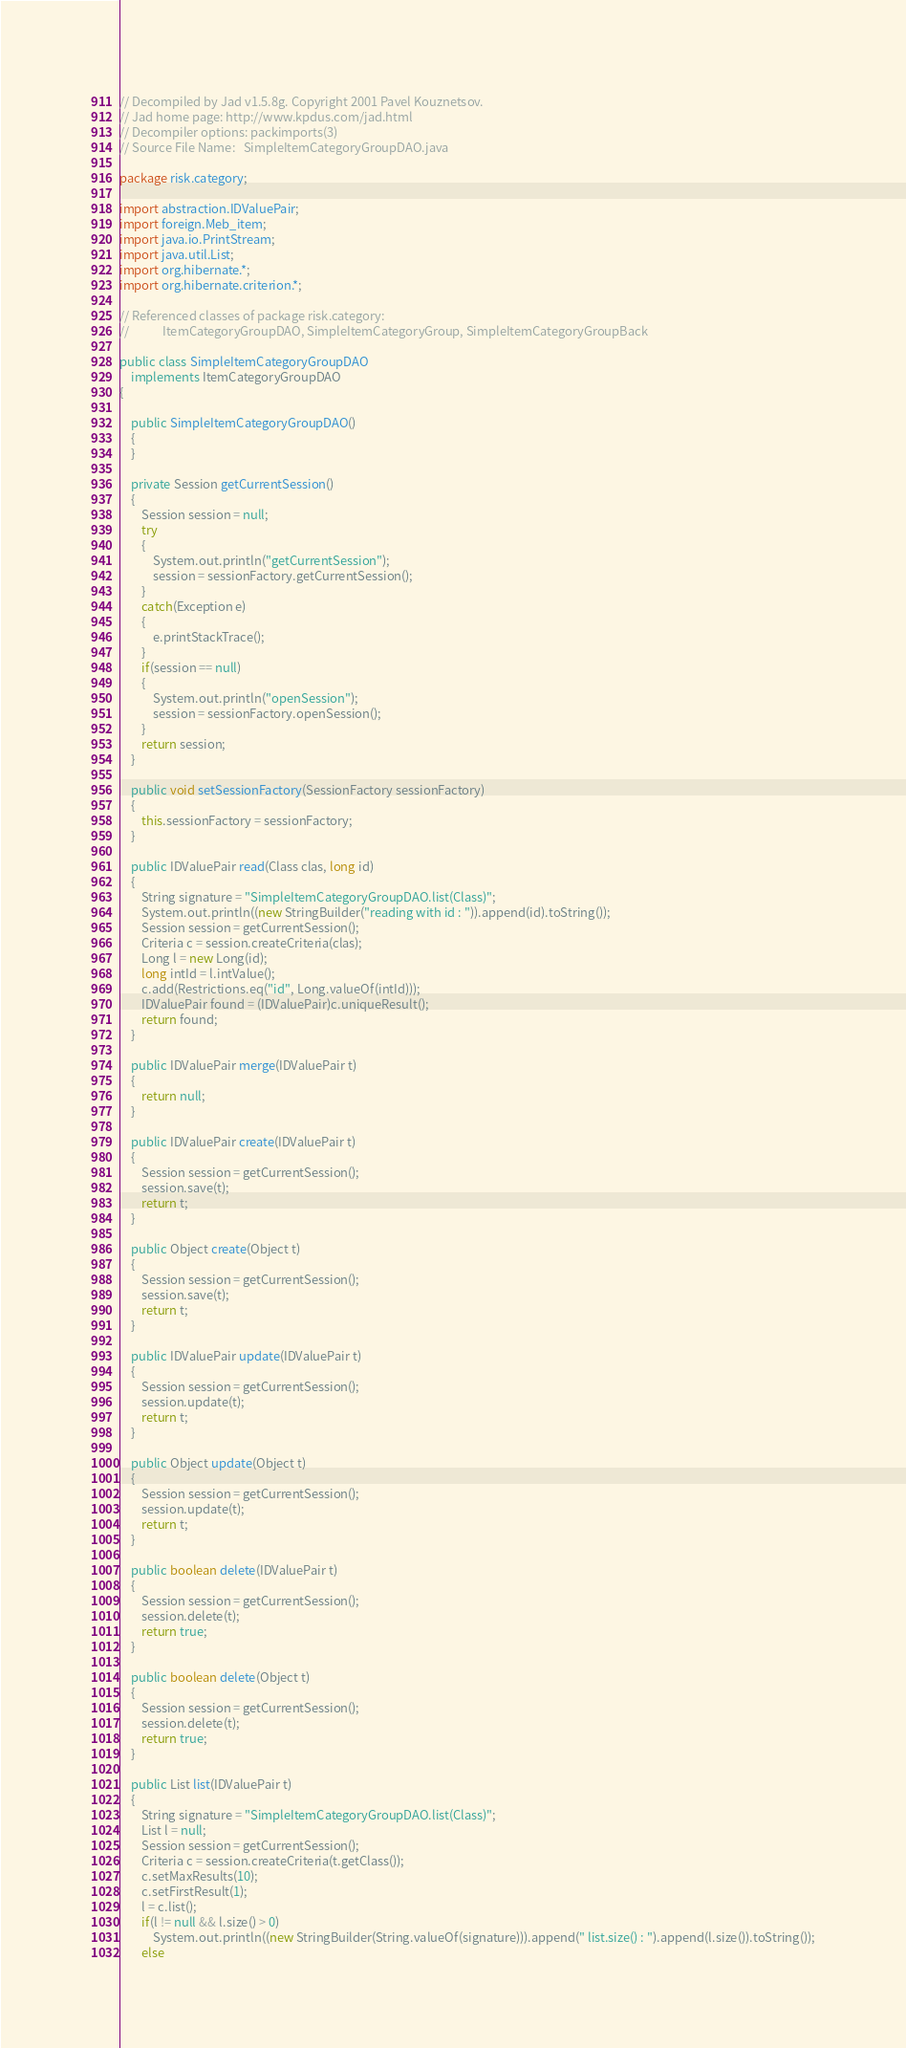Convert code to text. <code><loc_0><loc_0><loc_500><loc_500><_Java_>// Decompiled by Jad v1.5.8g. Copyright 2001 Pavel Kouznetsov.
// Jad home page: http://www.kpdus.com/jad.html
// Decompiler options: packimports(3) 
// Source File Name:   SimpleItemCategoryGroupDAO.java

package risk.category;

import abstraction.IDValuePair;
import foreign.Meb_item;
import java.io.PrintStream;
import java.util.List;
import org.hibernate.*;
import org.hibernate.criterion.*;

// Referenced classes of package risk.category:
//            ItemCategoryGroupDAO, SimpleItemCategoryGroup, SimpleItemCategoryGroupBack

public class SimpleItemCategoryGroupDAO
    implements ItemCategoryGroupDAO
{

    public SimpleItemCategoryGroupDAO()
    {
    }

    private Session getCurrentSession()
    {
        Session session = null;
        try
        {
            System.out.println("getCurrentSession");
            session = sessionFactory.getCurrentSession();
        }
        catch(Exception e)
        {
            e.printStackTrace();
        }
        if(session == null)
        {
            System.out.println("openSession");
            session = sessionFactory.openSession();
        }
        return session;
    }

    public void setSessionFactory(SessionFactory sessionFactory)
    {
        this.sessionFactory = sessionFactory;
    }

    public IDValuePair read(Class clas, long id)
    {
        String signature = "SimpleItemCategoryGroupDAO.list(Class)";
        System.out.println((new StringBuilder("reading with id : ")).append(id).toString());
        Session session = getCurrentSession();
        Criteria c = session.createCriteria(clas);
        Long l = new Long(id);
        long intId = l.intValue();
        c.add(Restrictions.eq("id", Long.valueOf(intId)));
        IDValuePair found = (IDValuePair)c.uniqueResult();
        return found;
    }

    public IDValuePair merge(IDValuePair t)
    {
        return null;
    }

    public IDValuePair create(IDValuePair t)
    {
        Session session = getCurrentSession();
        session.save(t);
        return t;
    }

    public Object create(Object t)
    {
        Session session = getCurrentSession();
        session.save(t);
        return t;
    }

    public IDValuePair update(IDValuePair t)
    {
        Session session = getCurrentSession();
        session.update(t);
        return t;
    }

    public Object update(Object t)
    {
        Session session = getCurrentSession();
        session.update(t);
        return t;
    }

    public boolean delete(IDValuePair t)
    {
        Session session = getCurrentSession();
        session.delete(t);
        return true;
    }

    public boolean delete(Object t)
    {
        Session session = getCurrentSession();
        session.delete(t);
        return true;
    }

    public List list(IDValuePair t)
    {
        String signature = "SimpleItemCategoryGroupDAO.list(Class)";
        List l = null;
        Session session = getCurrentSession();
        Criteria c = session.createCriteria(t.getClass());
        c.setMaxResults(10);
        c.setFirstResult(1);
        l = c.list();
        if(l != null && l.size() > 0)
            System.out.println((new StringBuilder(String.valueOf(signature))).append(" list.size() : ").append(l.size()).toString());
        else</code> 